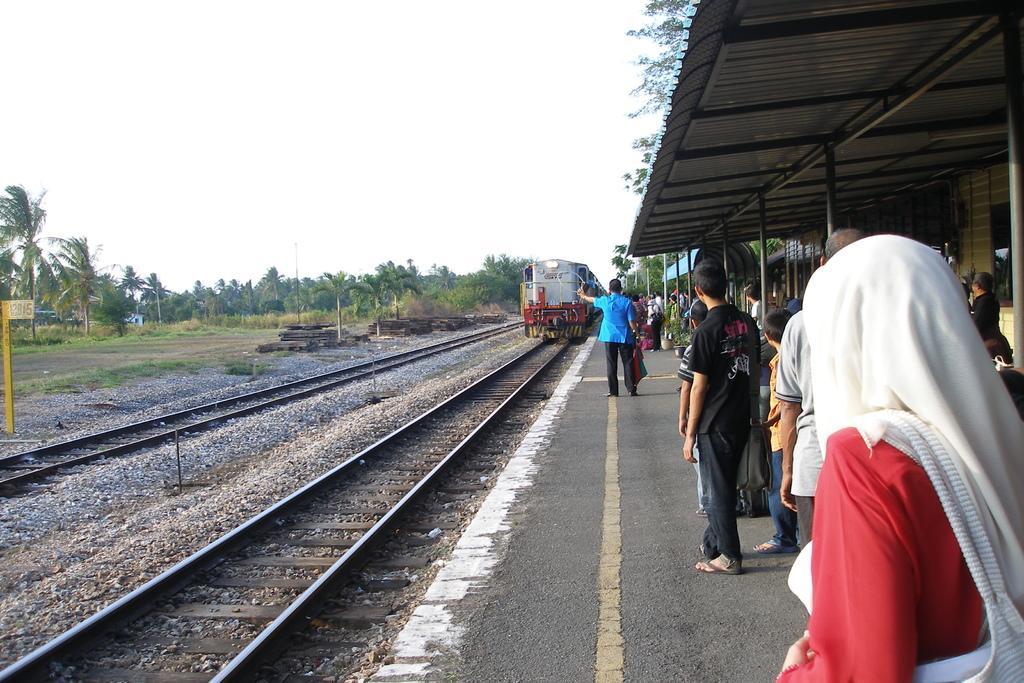Could you give a brief overview of what you see in this image? In this image on the right side there are persons standing and there is a shelter and on top of the shelter there are leaves. In the center there is a train running on the railway track. On the left side there are trees and there is a railway track and on the ground there are stones and there's grass on the ground. 